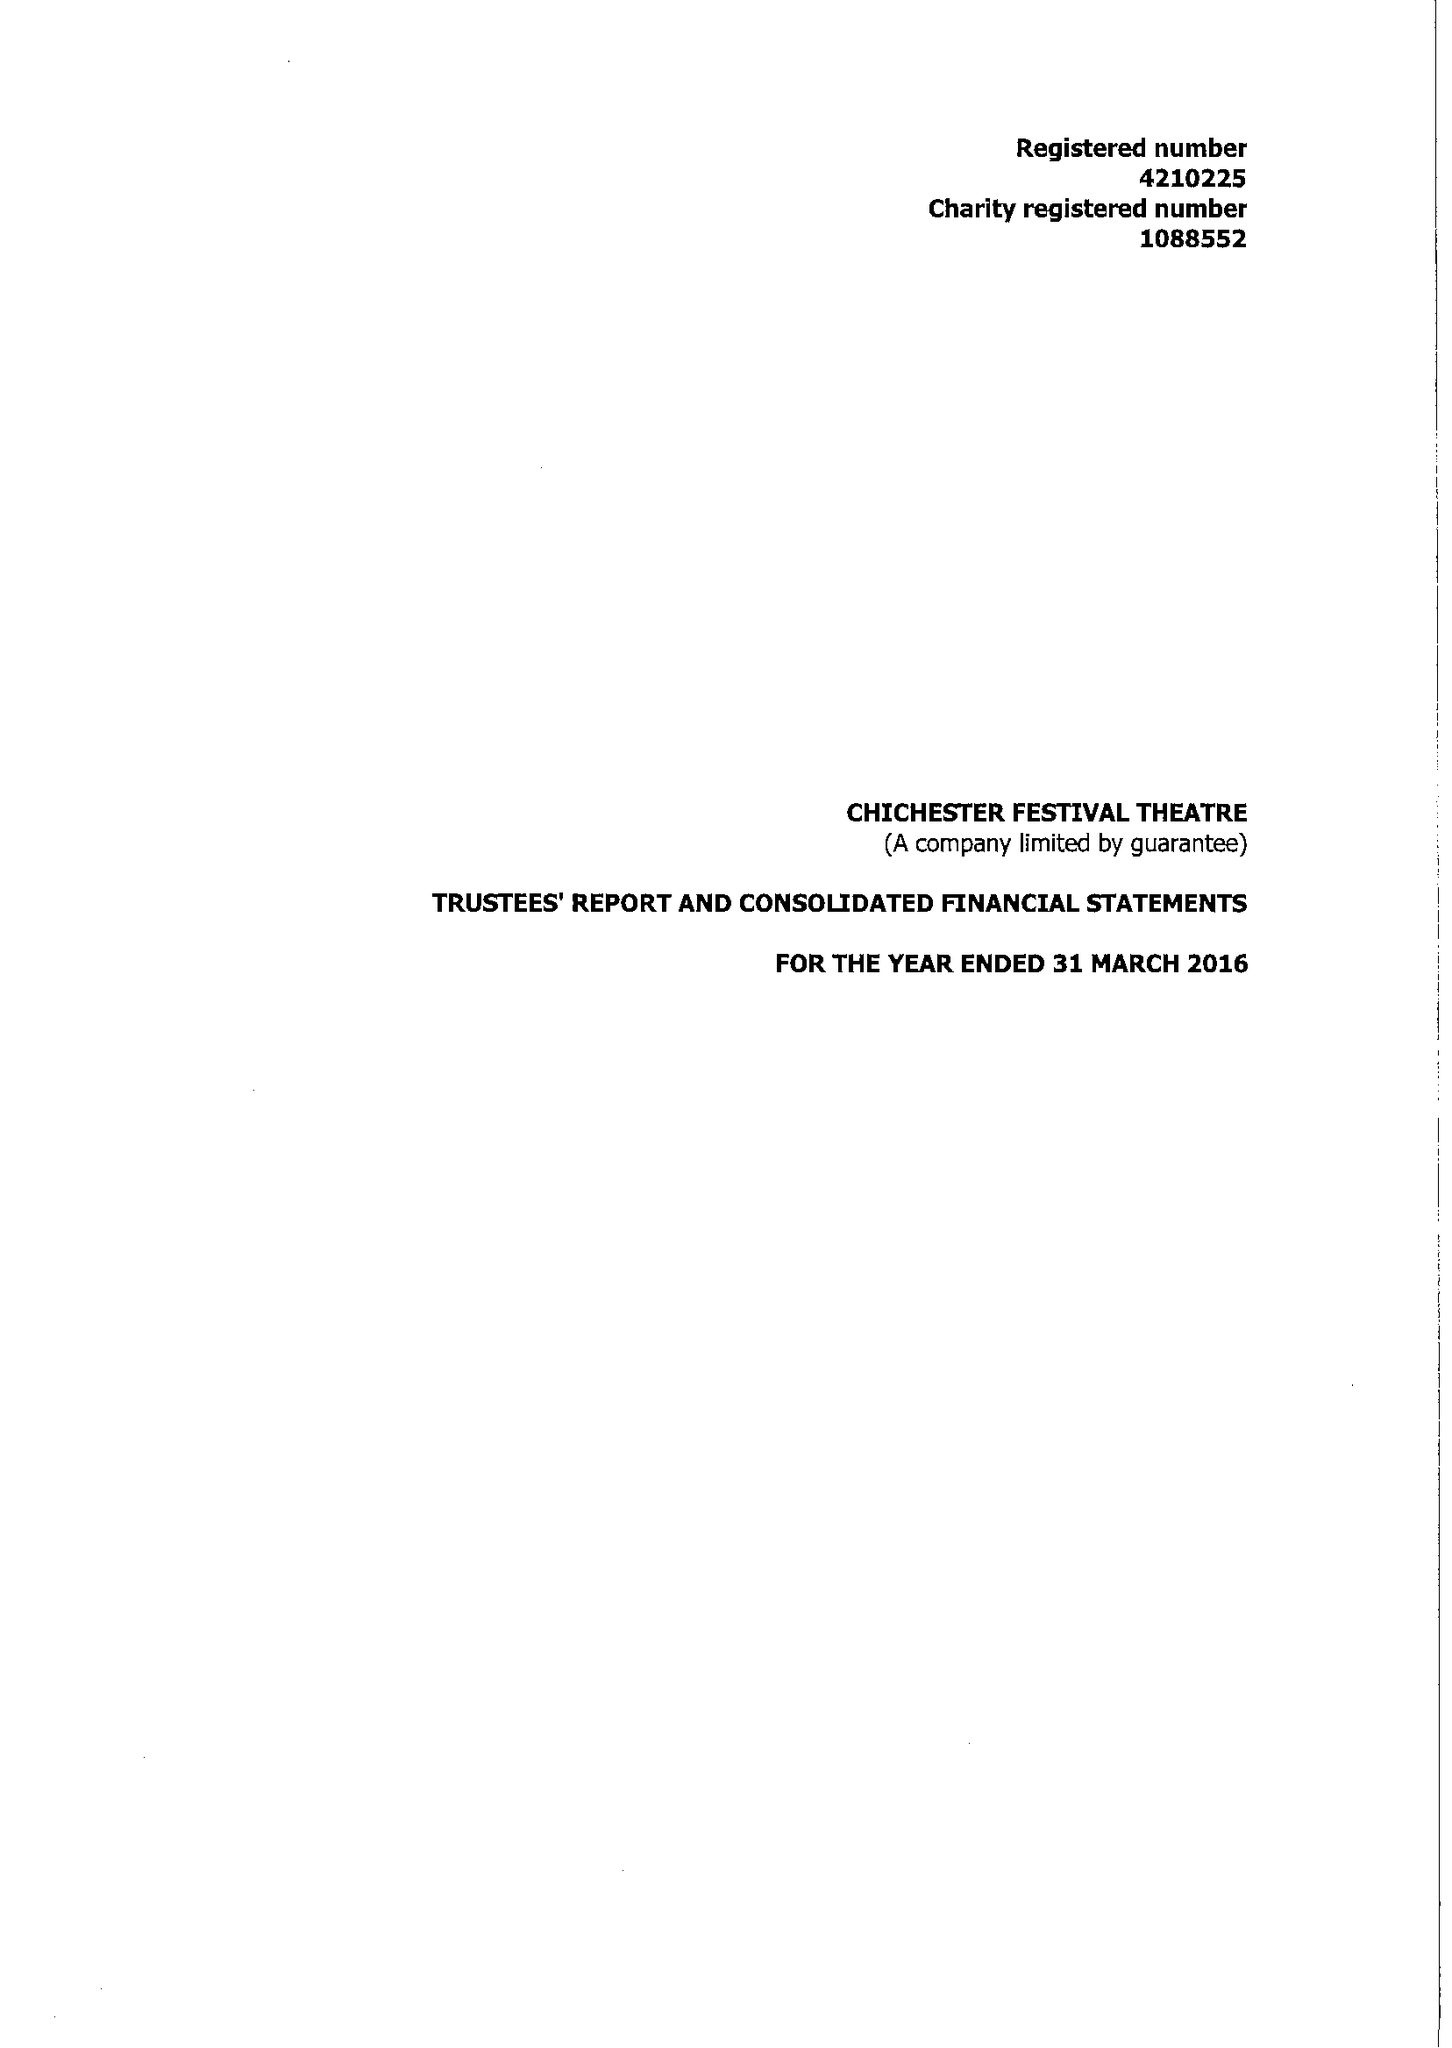What is the value for the address__postcode?
Answer the question using a single word or phrase. PO19 6AP 